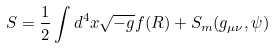<formula> <loc_0><loc_0><loc_500><loc_500>S = \frac { 1 } { 2 } \int d ^ { 4 } x \sqrt { - g } f ( R ) + S _ { m } ( g _ { \mu \nu } , \psi )</formula> 